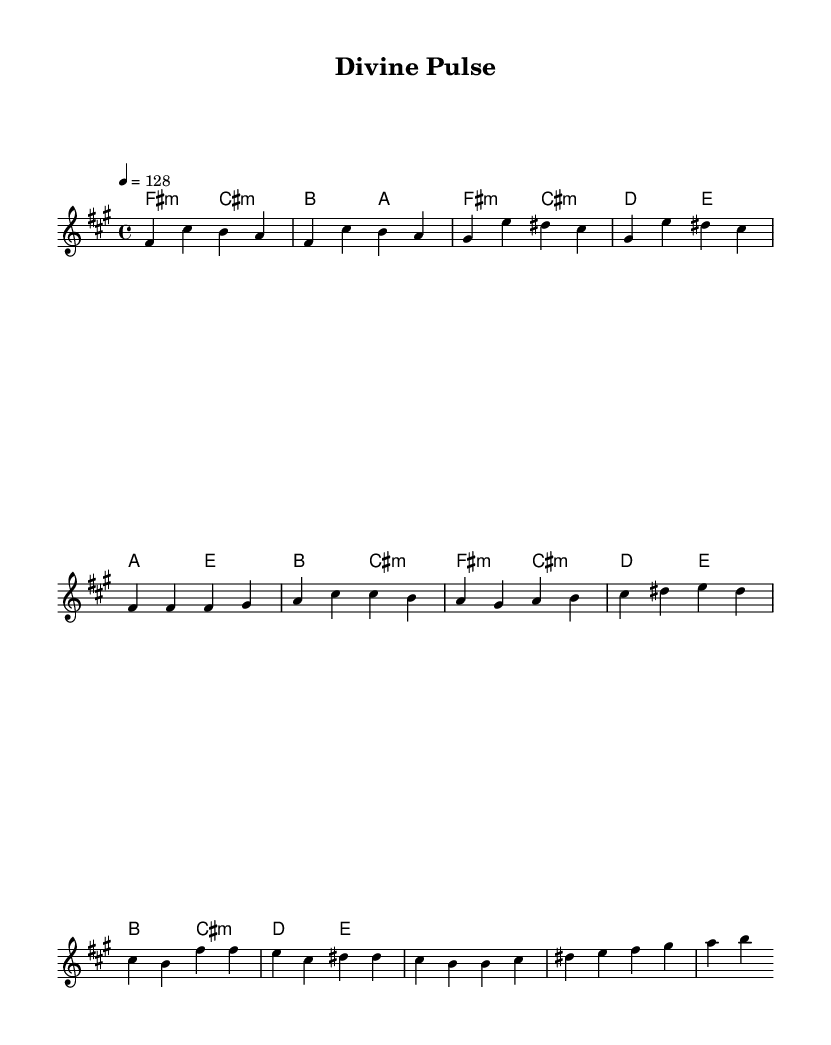What is the key signature of this music? The key signature appears at the beginning of the sheet music. It consists of three sharps, indicating that the piece is in F# minor.
Answer: F# minor What is the time signature of this music? The time signature is located right after the key signature. It shows a "4/4" notation, indicating that there are four beats per measure.
Answer: 4/4 What is the tempo of the piece? The tempo marking is indicated by the "4 = 128" notation. This means that there are 128 beats per minute in this piece.
Answer: 128 What section follows the bridge in this music? The bridge is a transition section in the song structure. The following section after the bridge, as indicated by the structure, is the chorus.
Answer: Chorus How many measures are in the chorus section? To find this, we can count the measures indicated in the "Chorus" section of the score. There are two measures in this section.
Answer: 2 What is the first chord used in the intro? When looking at the first line of the harmonies, the first chord is "F# minor," represented by "fis:m" in the chord notation.
Answer: F# minor What type of musical style does this piece represent? Given the upbeat tempo and structure, including sections like verse, pre-chorus, and chorus, this piece represents the K-Pop genre, known for its energetic and catchy style.
Answer: K-Pop 